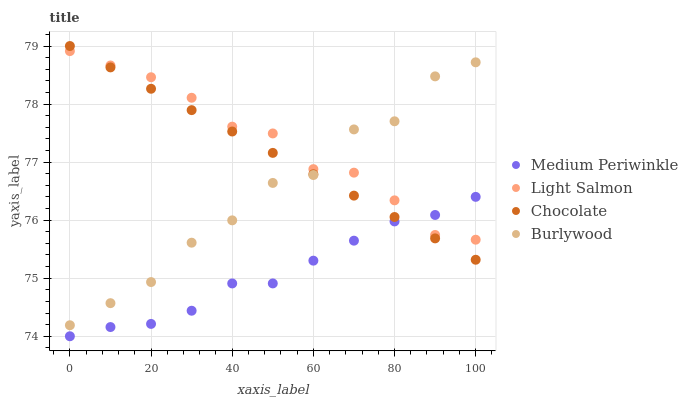Does Medium Periwinkle have the minimum area under the curve?
Answer yes or no. Yes. Does Light Salmon have the maximum area under the curve?
Answer yes or no. Yes. Does Light Salmon have the minimum area under the curve?
Answer yes or no. No. Does Medium Periwinkle have the maximum area under the curve?
Answer yes or no. No. Is Chocolate the smoothest?
Answer yes or no. Yes. Is Burlywood the roughest?
Answer yes or no. Yes. Is Light Salmon the smoothest?
Answer yes or no. No. Is Light Salmon the roughest?
Answer yes or no. No. Does Medium Periwinkle have the lowest value?
Answer yes or no. Yes. Does Light Salmon have the lowest value?
Answer yes or no. No. Does Chocolate have the highest value?
Answer yes or no. Yes. Does Light Salmon have the highest value?
Answer yes or no. No. Is Medium Periwinkle less than Burlywood?
Answer yes or no. Yes. Is Burlywood greater than Medium Periwinkle?
Answer yes or no. Yes. Does Chocolate intersect Burlywood?
Answer yes or no. Yes. Is Chocolate less than Burlywood?
Answer yes or no. No. Is Chocolate greater than Burlywood?
Answer yes or no. No. Does Medium Periwinkle intersect Burlywood?
Answer yes or no. No. 